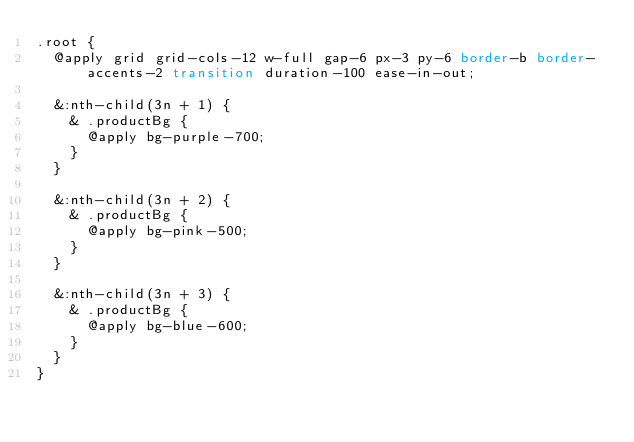<code> <loc_0><loc_0><loc_500><loc_500><_CSS_>.root {
  @apply grid grid-cols-12 w-full gap-6 px-3 py-6 border-b border-accents-2 transition duration-100 ease-in-out;

  &:nth-child(3n + 1) {
    & .productBg {
      @apply bg-purple-700;
    }
  }

  &:nth-child(3n + 2) {
    & .productBg {
      @apply bg-pink-500;
    }
  }

  &:nth-child(3n + 3) {
    & .productBg {
      @apply bg-blue-600;
    }
  }
}
</code> 